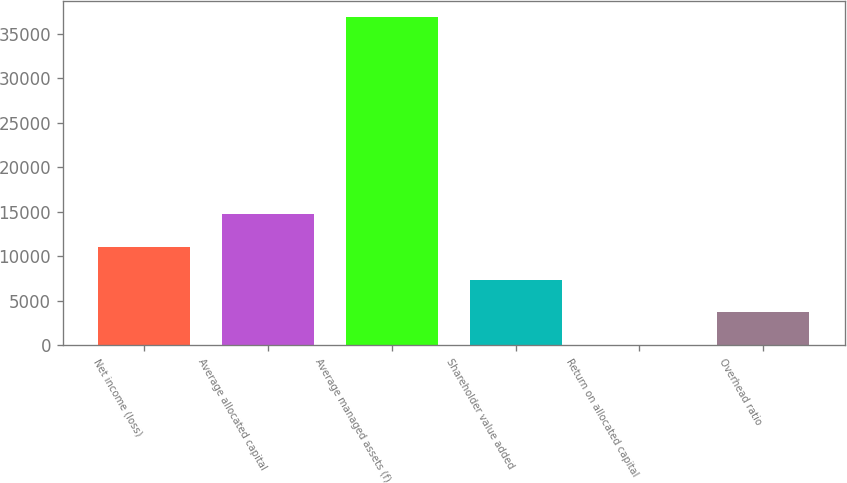<chart> <loc_0><loc_0><loc_500><loc_500><bar_chart><fcel>Net income (loss)<fcel>Average allocated capital<fcel>Average managed assets (f)<fcel>Shareholder value added<fcel>Return on allocated capital<fcel>Overhead ratio<nl><fcel>11073<fcel>14762<fcel>36896<fcel>7384<fcel>6<fcel>3695<nl></chart> 